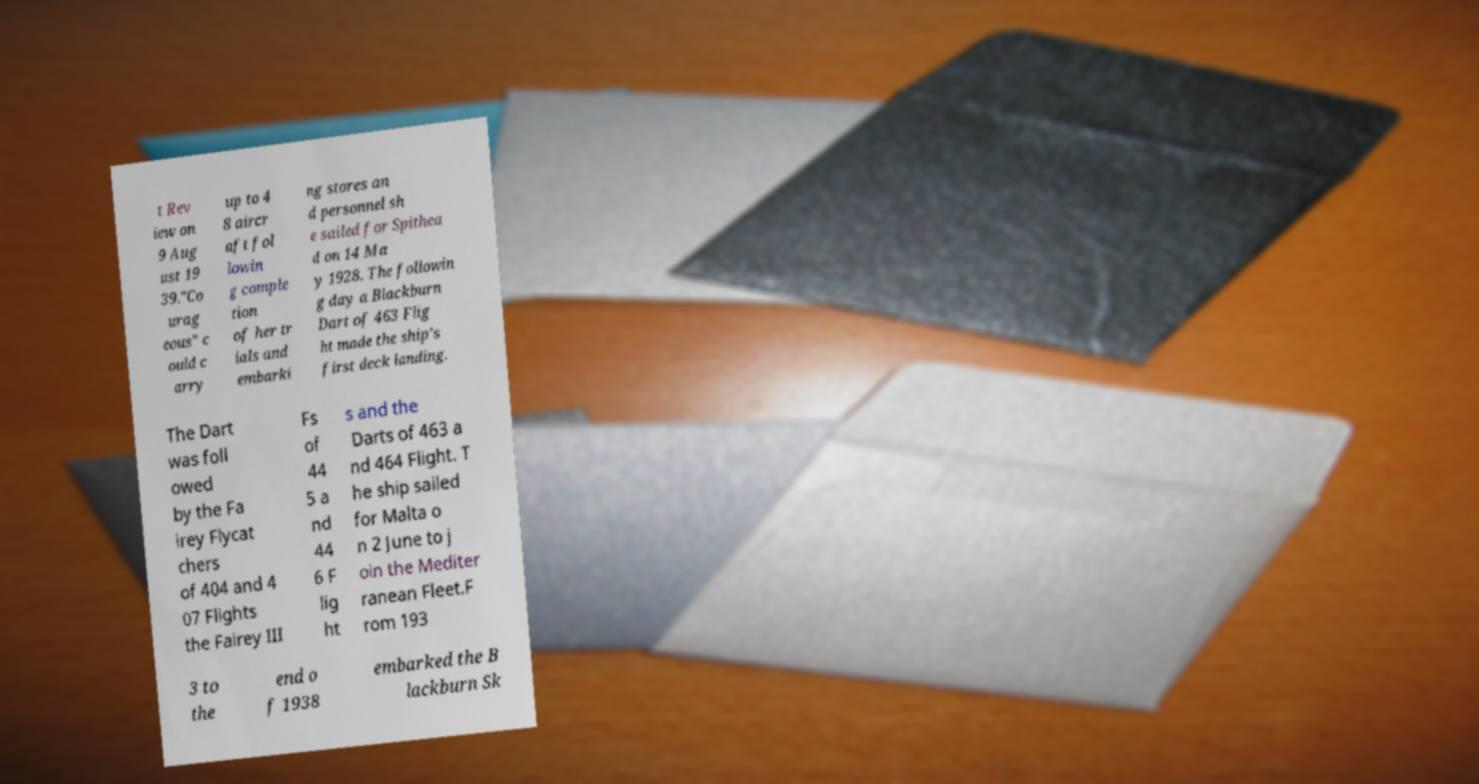What messages or text are displayed in this image? I need them in a readable, typed format. t Rev iew on 9 Aug ust 19 39."Co urag eous" c ould c arry up to 4 8 aircr aft fol lowin g comple tion of her tr ials and embarki ng stores an d personnel sh e sailed for Spithea d on 14 Ma y 1928. The followin g day a Blackburn Dart of 463 Flig ht made the ship's first deck landing. The Dart was foll owed by the Fa irey Flycat chers of 404 and 4 07 Flights the Fairey III Fs of 44 5 a nd 44 6 F lig ht s and the Darts of 463 a nd 464 Flight. T he ship sailed for Malta o n 2 June to j oin the Mediter ranean Fleet.F rom 193 3 to the end o f 1938 embarked the B lackburn Sk 